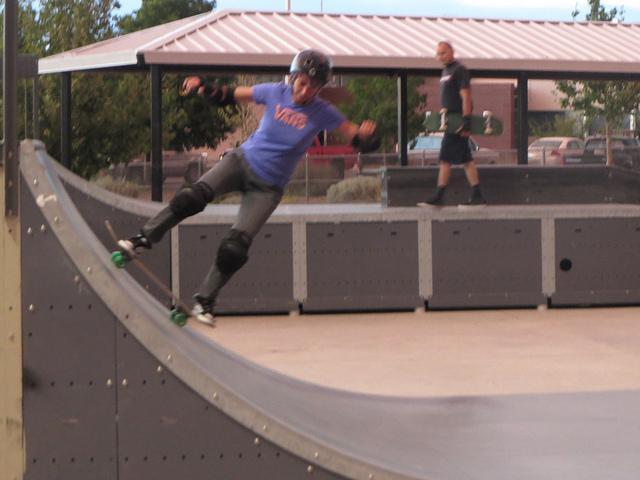How many people are in this picture?
Give a very brief answer. 2. How many people are there?
Give a very brief answer. 2. How many bikes are behind the clock?
Give a very brief answer. 0. 